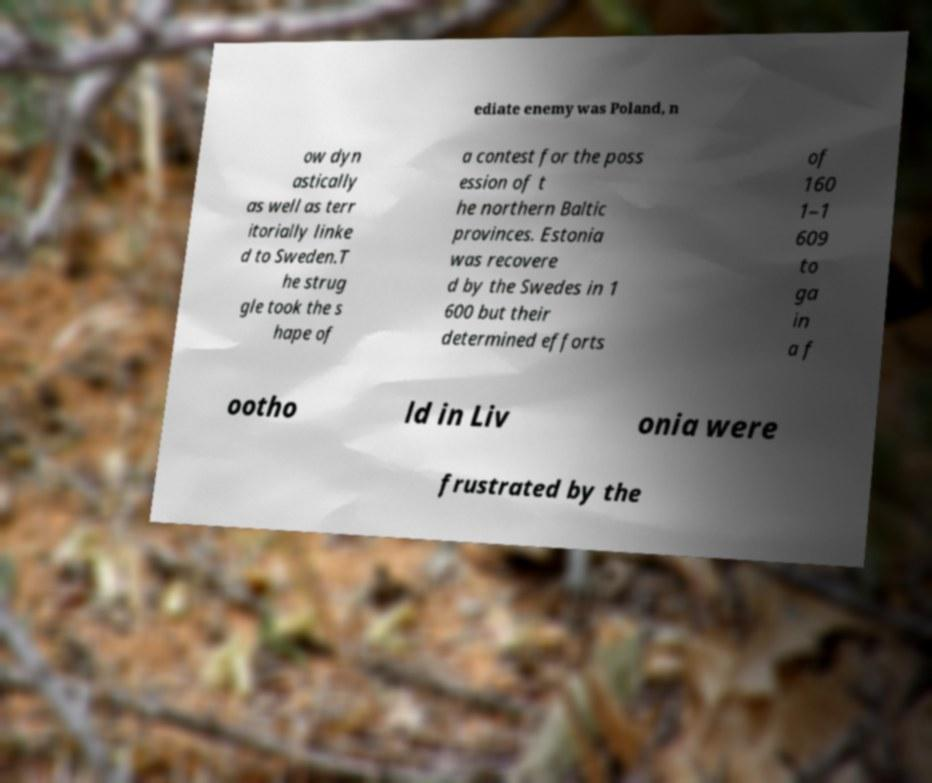Please read and relay the text visible in this image. What does it say? ediate enemy was Poland, n ow dyn astically as well as terr itorially linke d to Sweden.T he strug gle took the s hape of a contest for the poss ession of t he northern Baltic provinces. Estonia was recovere d by the Swedes in 1 600 but their determined efforts of 160 1–1 609 to ga in a f ootho ld in Liv onia were frustrated by the 